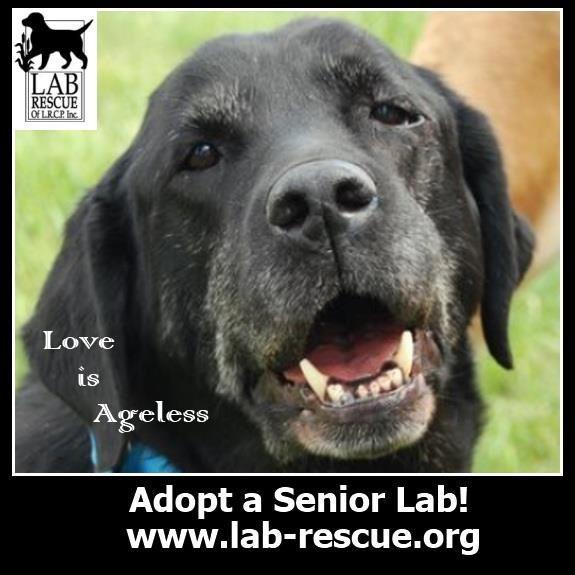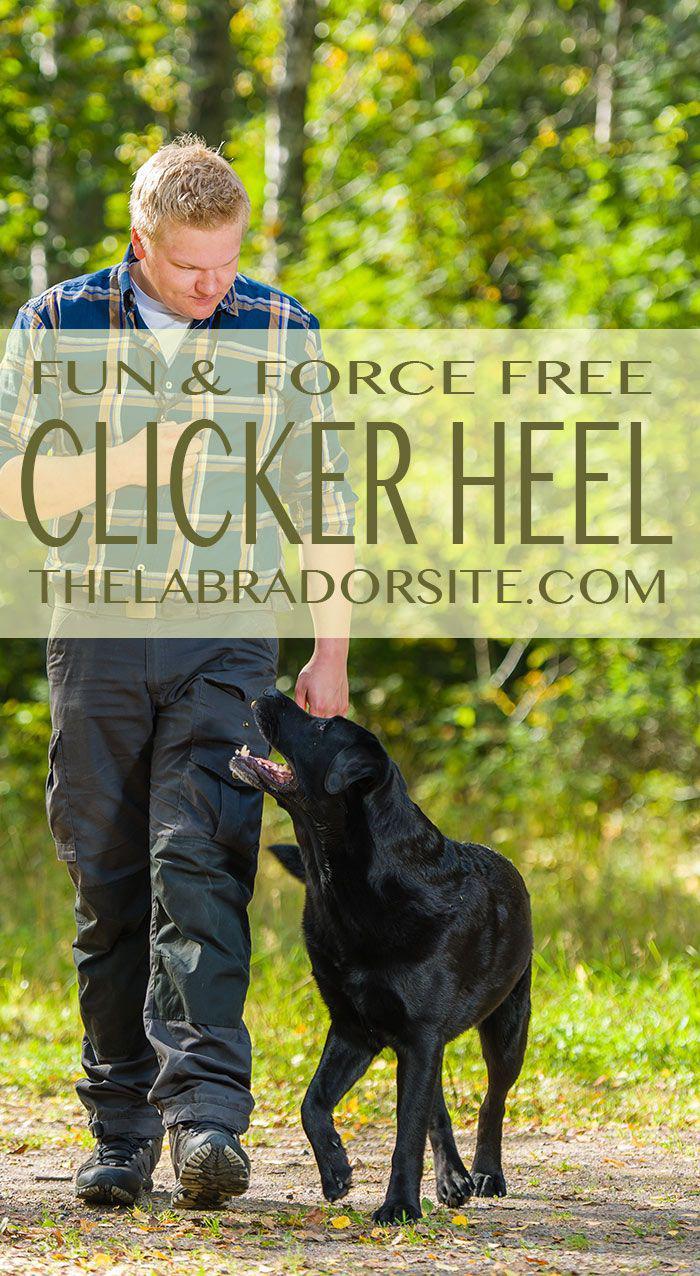The first image is the image on the left, the second image is the image on the right. Examine the images to the left and right. Is the description "One image shows a lone dog facing the right with his mouth open." accurate? Answer yes or no. No. The first image is the image on the left, the second image is the image on the right. For the images displayed, is the sentence "There is at least one human touching a dog." factually correct? Answer yes or no. Yes. 